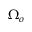Convert formula to latex. <formula><loc_0><loc_0><loc_500><loc_500>\Omega _ { o }</formula> 